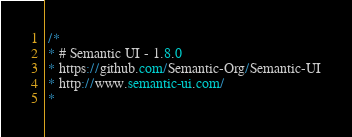Convert code to text. <code><loc_0><loc_0><loc_500><loc_500><_CSS_> /*
 * # Semantic UI - 1.8.0
 * https://github.com/Semantic-Org/Semantic-UI
 * http://www.semantic-ui.com/
 *</code> 